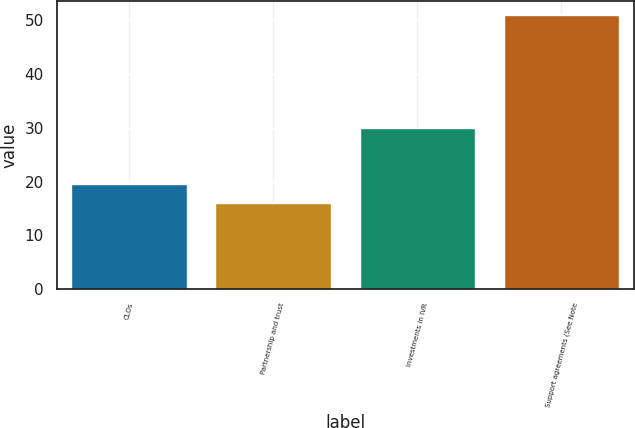Convert chart. <chart><loc_0><loc_0><loc_500><loc_500><bar_chart><fcel>CLOs<fcel>Partnership and trust<fcel>Investments in IVR<fcel>Support agreements (See Note<nl><fcel>19.59<fcel>16.1<fcel>30<fcel>51<nl></chart> 